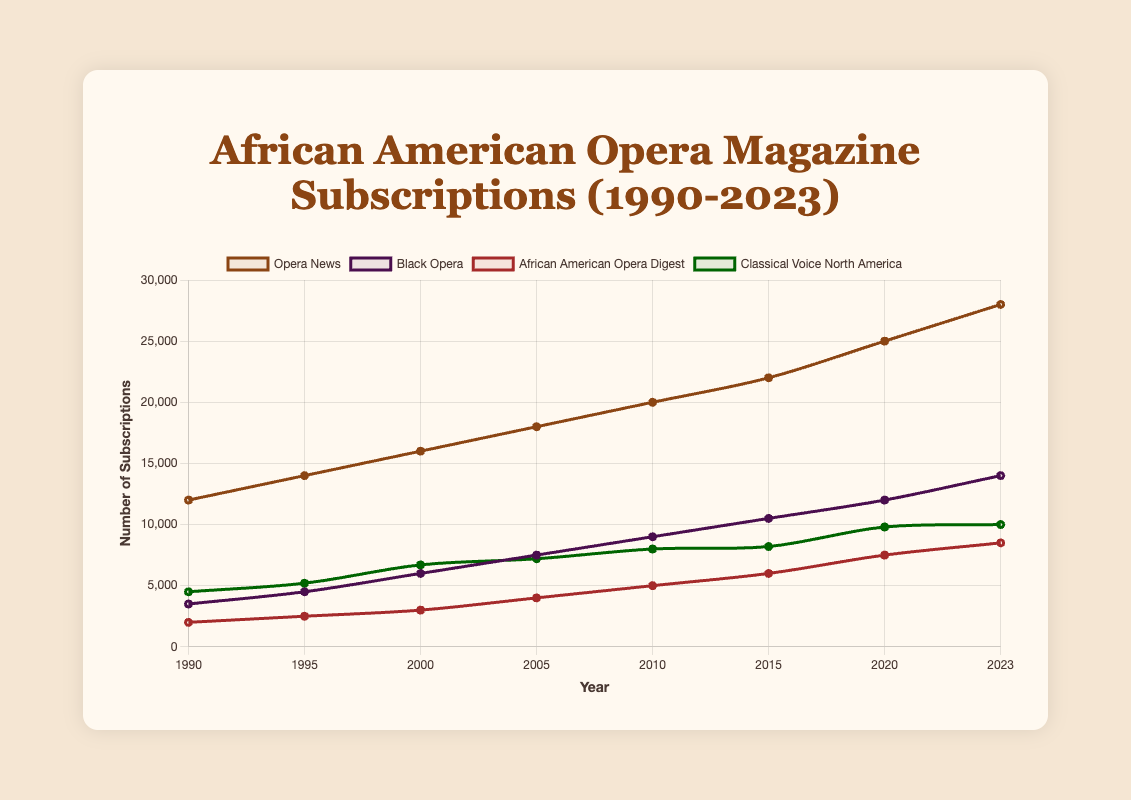What's the trend of "Black Opera" subscriptions from 1990 to 2023? "Black Opera" subscriptions show a consistent upward trend from 1990 to 2023, increasing from 3,500 subscriptions in 1990 to 14,000 subscriptions in 2023. This indicates a steady growth over the years.
Answer: Upward trend Which magazine saw the highest number of subscriptions in 2023? In 2023, "Opera News" has the highest number of subscriptions, reaching 28,000. This can be observed as the topmost line in the plot for that year.
Answer: Opera News What is the average number of subscriptions for "African American Opera Digest" from 1990 to 2023? To find the average, sum up the subscriptions from all years and then divide by the number of years. (2000 + 2500 + 3000 + 4000 + 5000 + 6000 + 7500 + 8500) / 8 = 38500 / 8 = 4812.5
Answer: 4812.5 Between 1990 and 2023, which magazine shows the greatest percentage increase in subscriptions? To determine the greatest percentage increase, calculate the percentage increase for each magazine from 1990 to 2023. "Black Opera" increases from 3,500 to 14,000, resulting in a percentage increase of ((14000 - 3500) / 3500) * 100 = 300%. This is the highest among all the magazines.
Answer: Black Opera How does the subscription trend of "Classical Voice North America" compare to "Opera News" from 1990 to 2023? "Opera News" shows a steady and higher increase in subscriptions compared to "Classical Voice North America". "Opera News" grows from 12,000 to 28,000, while "Classical Voice North America" grows from 4,500 to 10,000. "Opera News" has a more significant rise and remains consistently higher.
Answer: Opera News grows more significantly What is the difference in subscriptions between "Opera News" and "African American Opera Digest" in the year 2020? In 2020, "Opera News" had 25,000 subscriptions and "African American Opera Digest" had 7,500. The difference is calculated by subtracting the smaller value from the larger one: 25,000 - 7,500 = 17,500.
Answer: 17,500 What year did "Black Opera" surpass "Classical Voice North America" in subscriptions? The line representing "Black Opera" surpasses "Classical Voice North America" between 2000 and 2005. "Black Opera" subscriptions are 6,000 in 2000 and 7,500 in 2005; "Classical Voice North America" has 6,700 in 2000 and 7,200 in 2005. The surpassing occurs at 2000.
Answer: 2000 Among all magazines, which one had the least growth in subscription numbers from 1990 to 2023? "African American Opera Digest" had the smallest increase, from 2,000 in 1990 to 8,500 in 2023, a total increase of 6,500. This is the least growth compared to the other magazines.
Answer: African American Opera Digest 